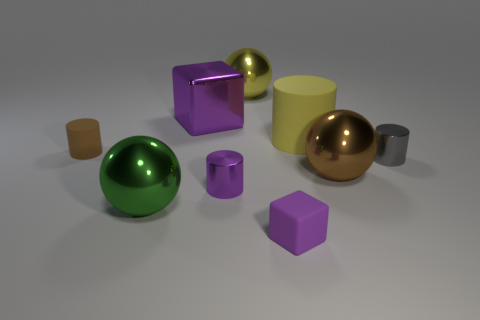How many objects are big green metal things or cylinders that are to the right of the brown rubber cylinder?
Offer a very short reply. 4. What material is the gray object?
Provide a short and direct response. Metal. What material is the small thing that is the same shape as the large purple metallic object?
Give a very brief answer. Rubber. The block that is behind the large object that is in front of the large brown sphere is what color?
Your answer should be very brief. Purple. How many matte things are either purple things or large things?
Offer a very short reply. 2. Is the large purple cube made of the same material as the yellow sphere?
Offer a terse response. Yes. What material is the purple block behind the purple metallic object that is in front of the small matte cylinder made of?
Offer a terse response. Metal. How many big things are either yellow shiny balls or brown metal objects?
Keep it short and to the point. 2. What size is the rubber block?
Your answer should be very brief. Small. Is the number of tiny purple blocks that are on the left side of the big green thing greater than the number of big brown metal spheres?
Make the answer very short. No. 